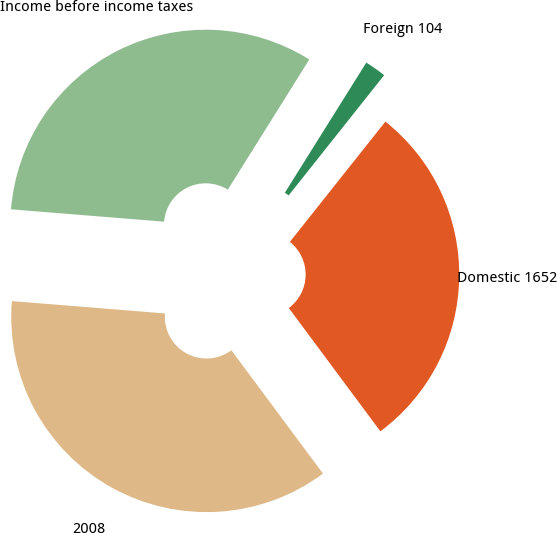Convert chart to OTSL. <chart><loc_0><loc_0><loc_500><loc_500><pie_chart><fcel>2008<fcel>Domestic 1652<fcel>Foreign 104<fcel>Income before income taxes<nl><fcel>36.45%<fcel>29.15%<fcel>1.78%<fcel>32.62%<nl></chart> 